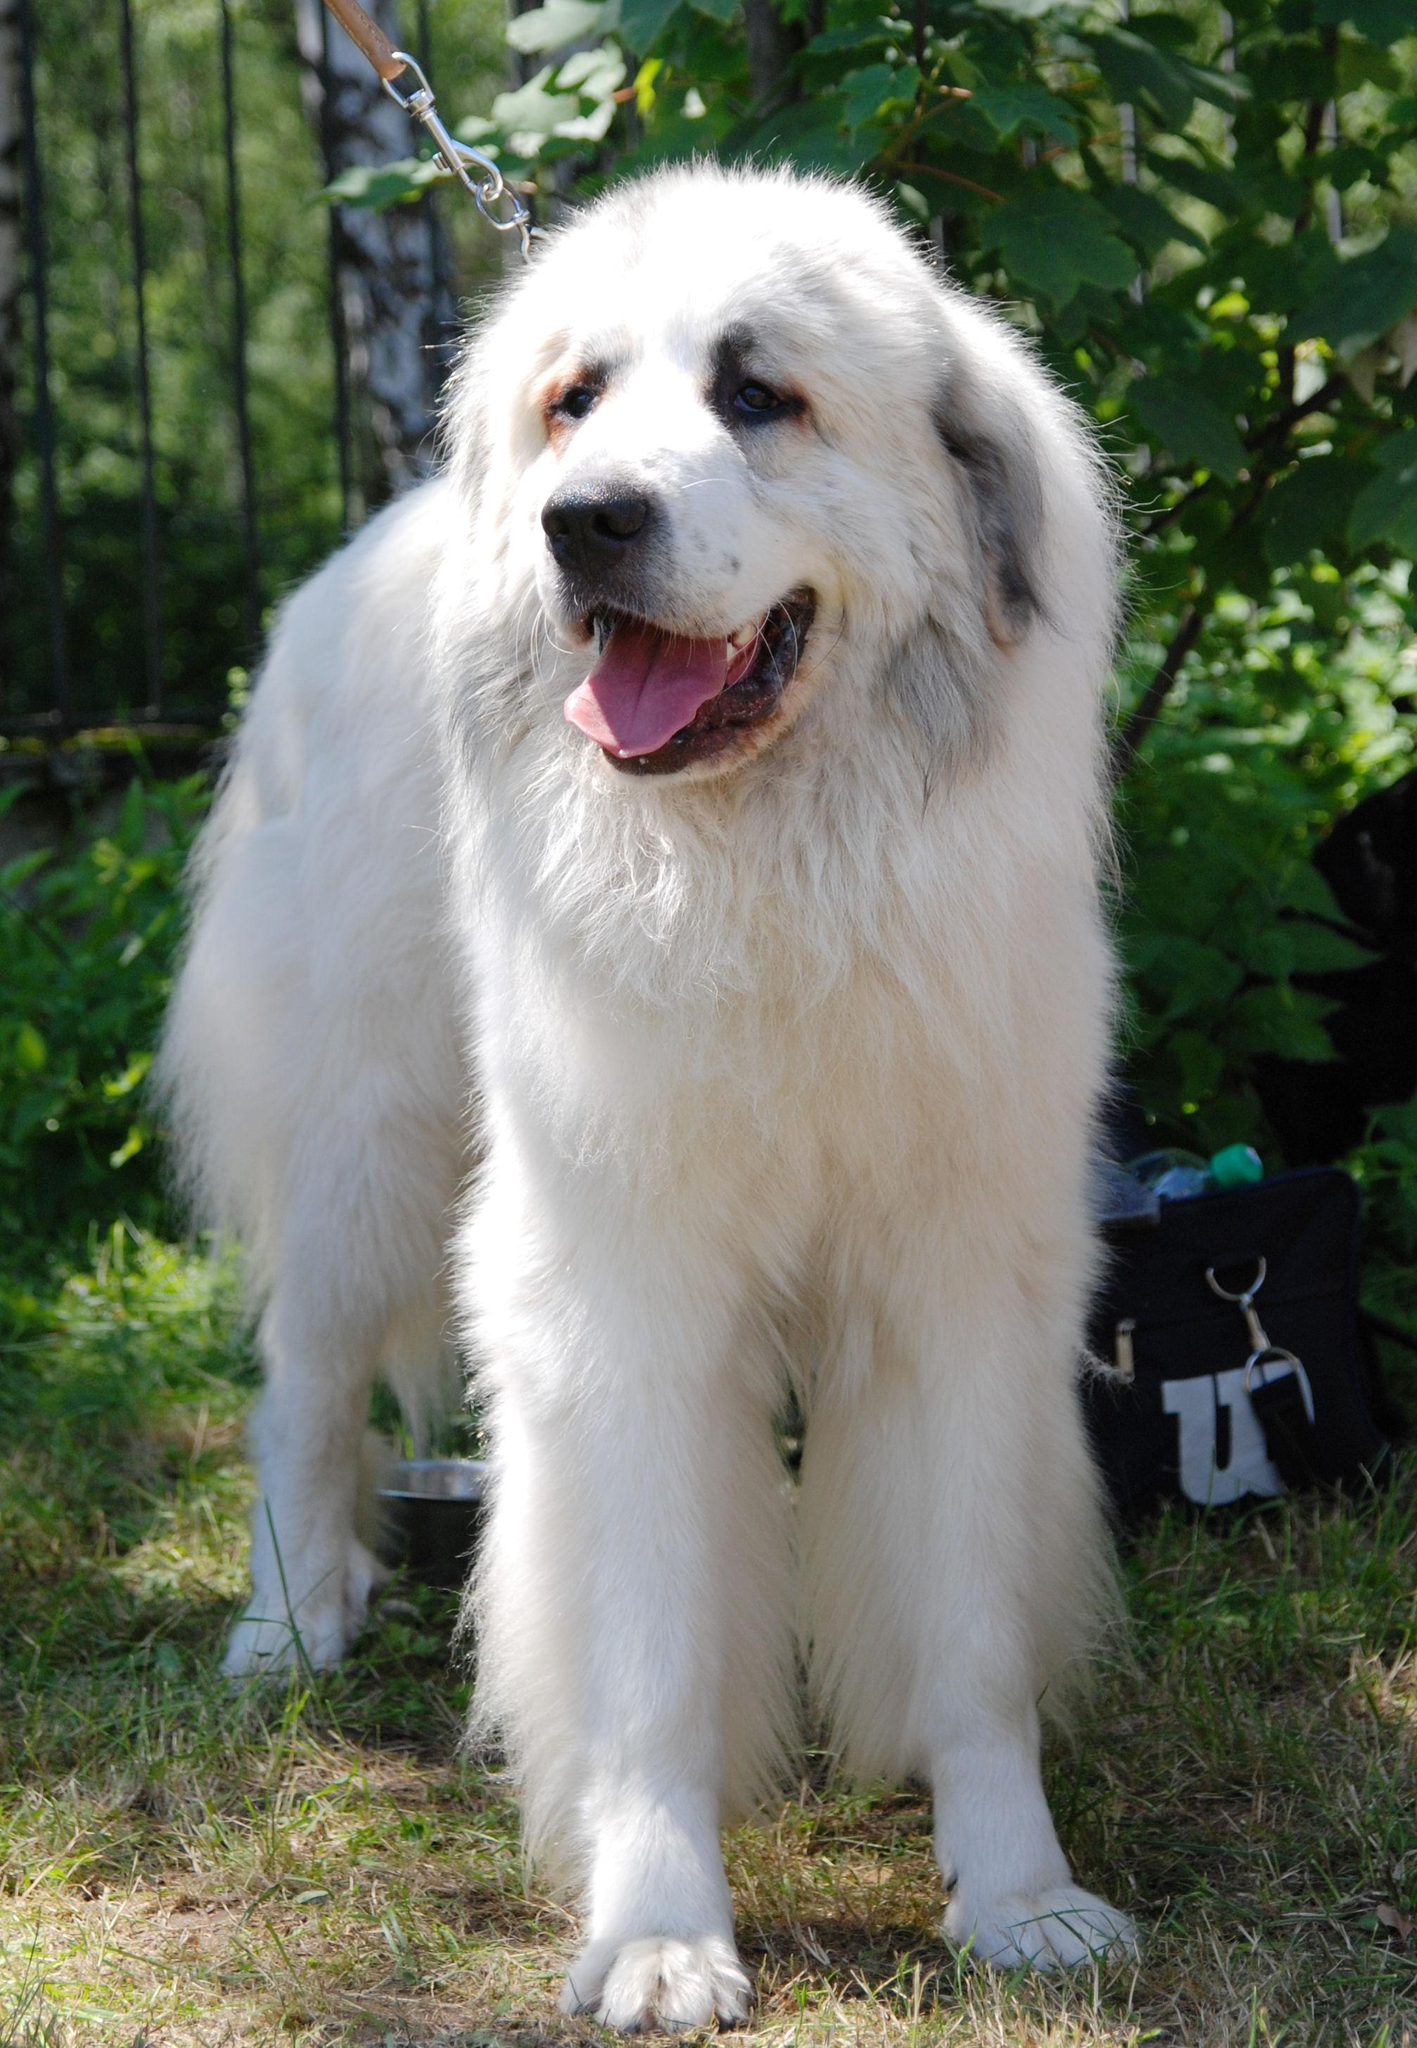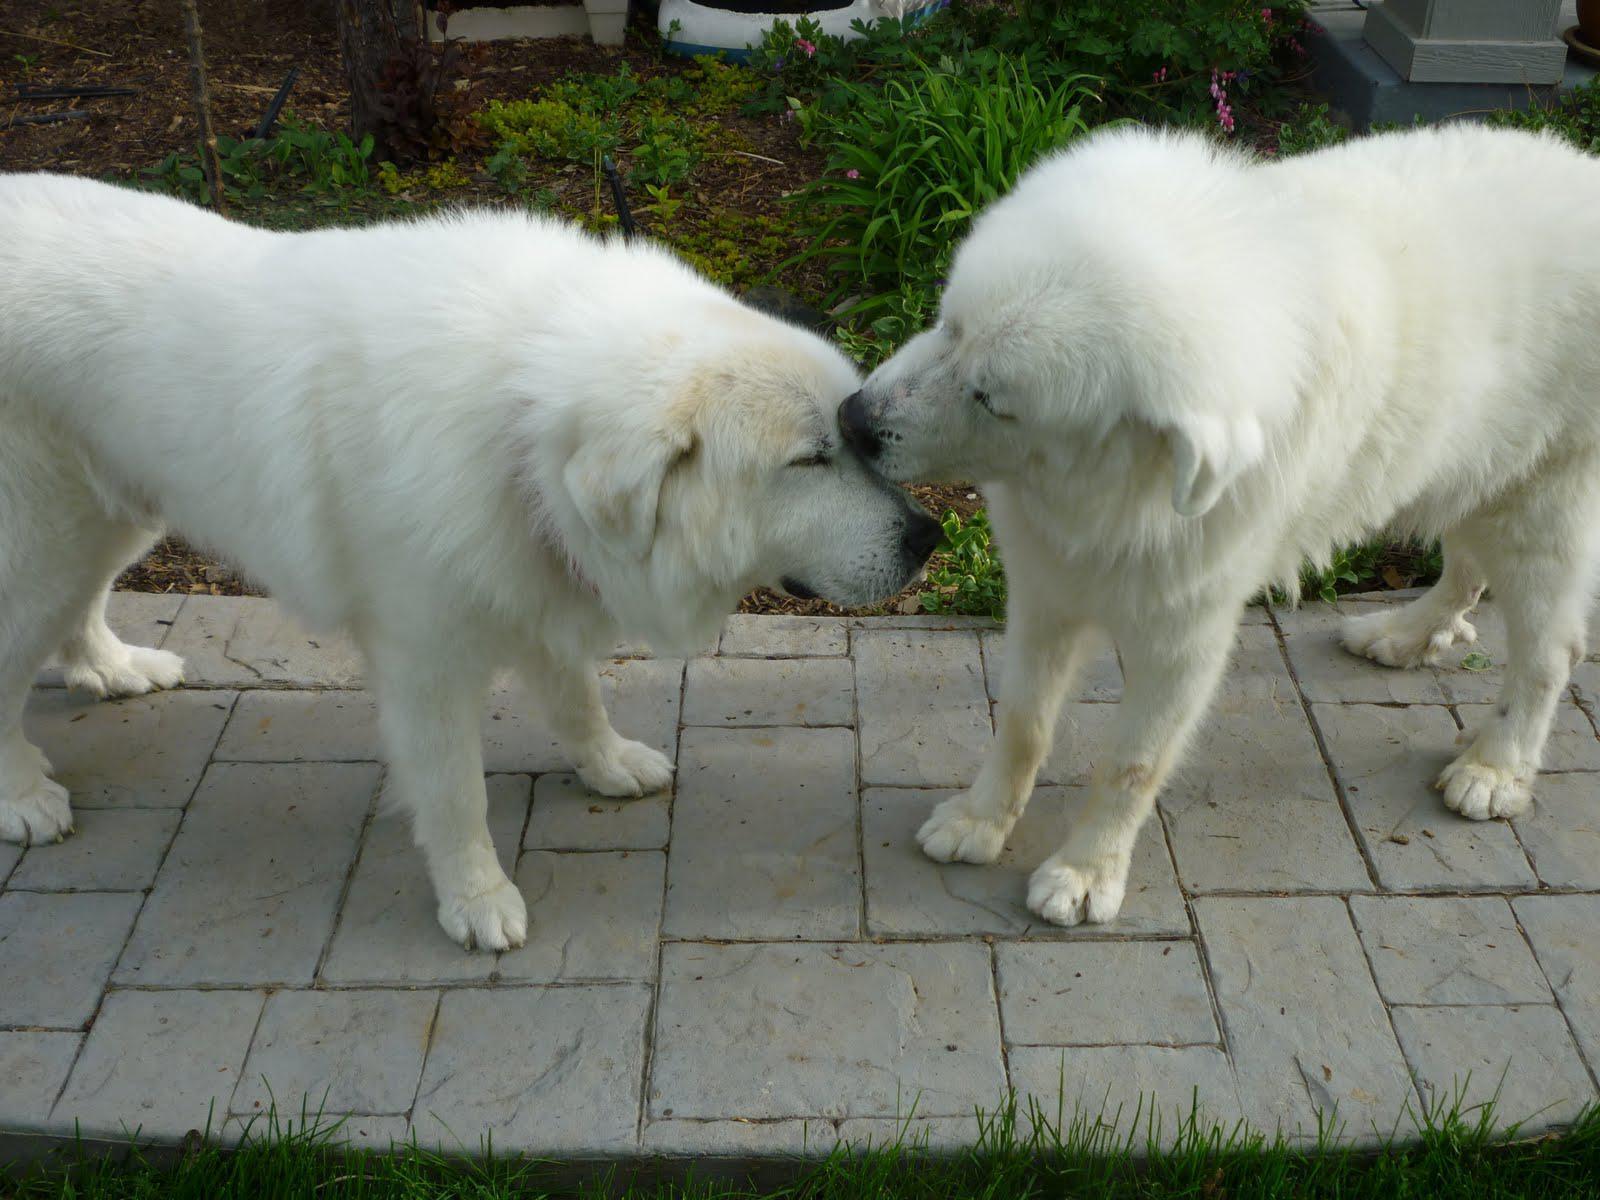The first image is the image on the left, the second image is the image on the right. Given the left and right images, does the statement "Two furry white dogs pose standing close together outdoors, in one image." hold true? Answer yes or no. Yes. The first image is the image on the left, the second image is the image on the right. Given the left and right images, does the statement "An image contains at least two dogs." hold true? Answer yes or no. Yes. 